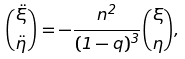Convert formula to latex. <formula><loc_0><loc_0><loc_500><loc_500>\binom { \ddot { \xi } } { \ddot { \eta } } = - \frac { n ^ { 2 } } { ( 1 - q ) ^ { 3 } } \binom { \xi } { \eta } ,</formula> 